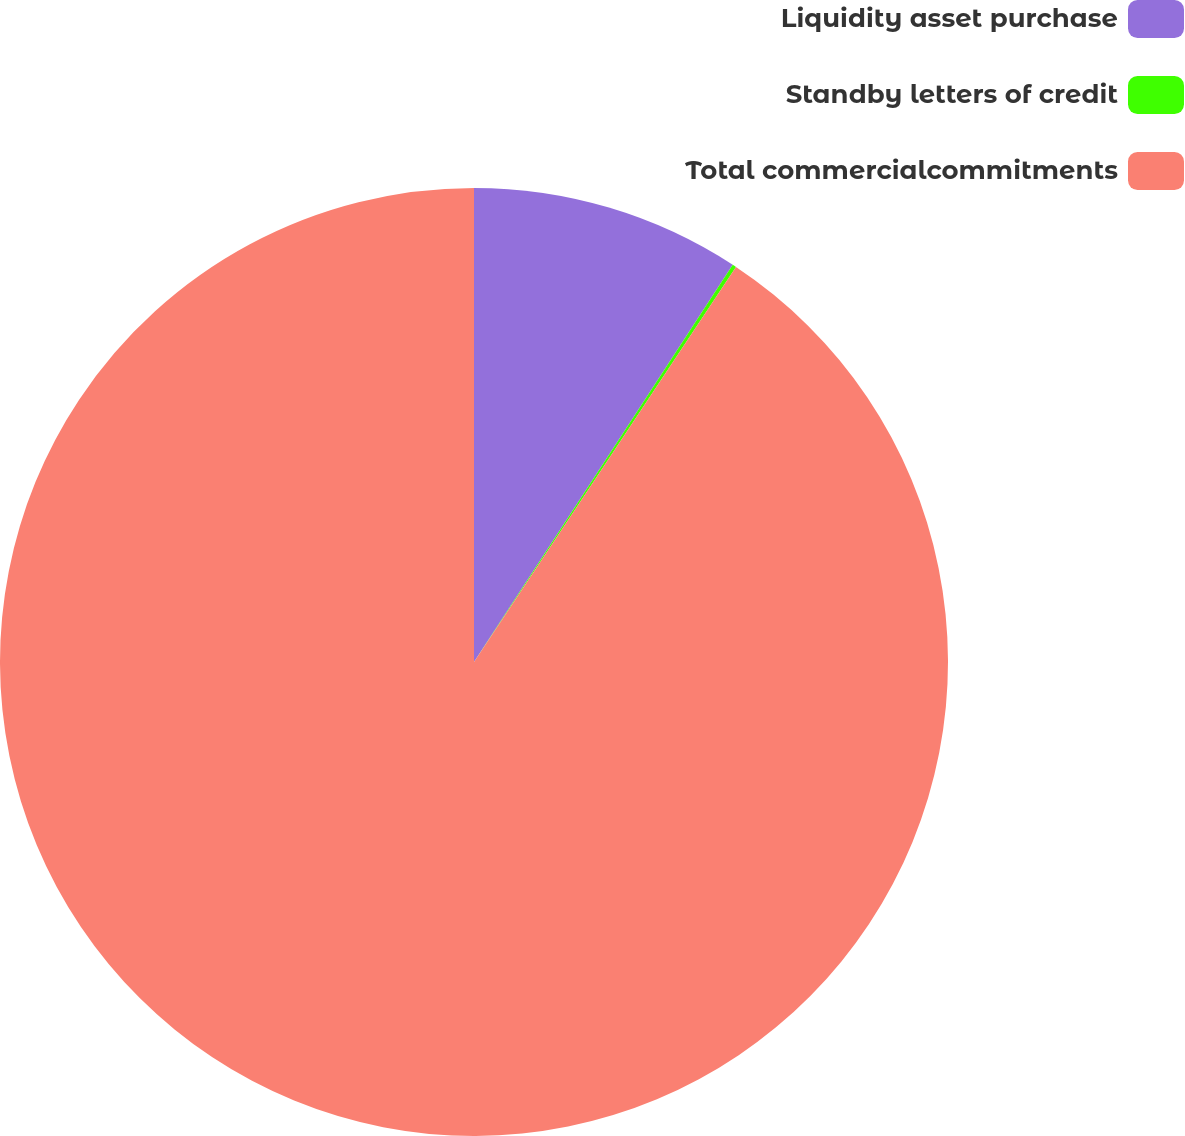<chart> <loc_0><loc_0><loc_500><loc_500><pie_chart><fcel>Liquidity asset purchase<fcel>Standby letters of credit<fcel>Total commercialcommitments<nl><fcel>9.19%<fcel>0.13%<fcel>90.68%<nl></chart> 